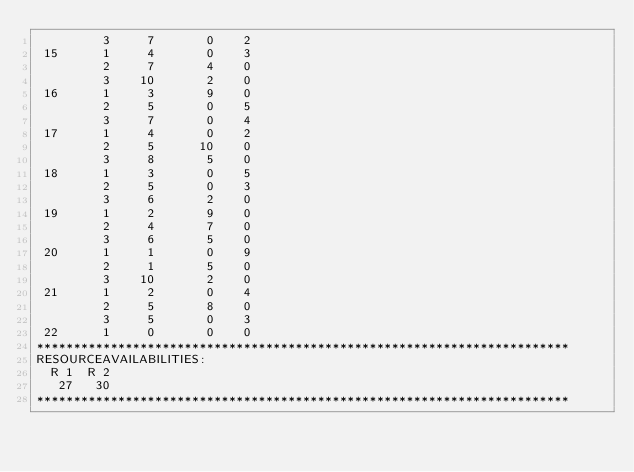Convert code to text. <code><loc_0><loc_0><loc_500><loc_500><_ObjectiveC_>         3     7       0    2
 15      1     4       0    3
         2     7       4    0
         3    10       2    0
 16      1     3       9    0
         2     5       0    5
         3     7       0    4
 17      1     4       0    2
         2     5      10    0
         3     8       5    0
 18      1     3       0    5
         2     5       0    3
         3     6       2    0
 19      1     2       9    0
         2     4       7    0
         3     6       5    0
 20      1     1       0    9
         2     1       5    0
         3    10       2    0
 21      1     2       0    4
         2     5       8    0
         3     5       0    3
 22      1     0       0    0
************************************************************************
RESOURCEAVAILABILITIES:
  R 1  R 2
   27   30
************************************************************************
</code> 